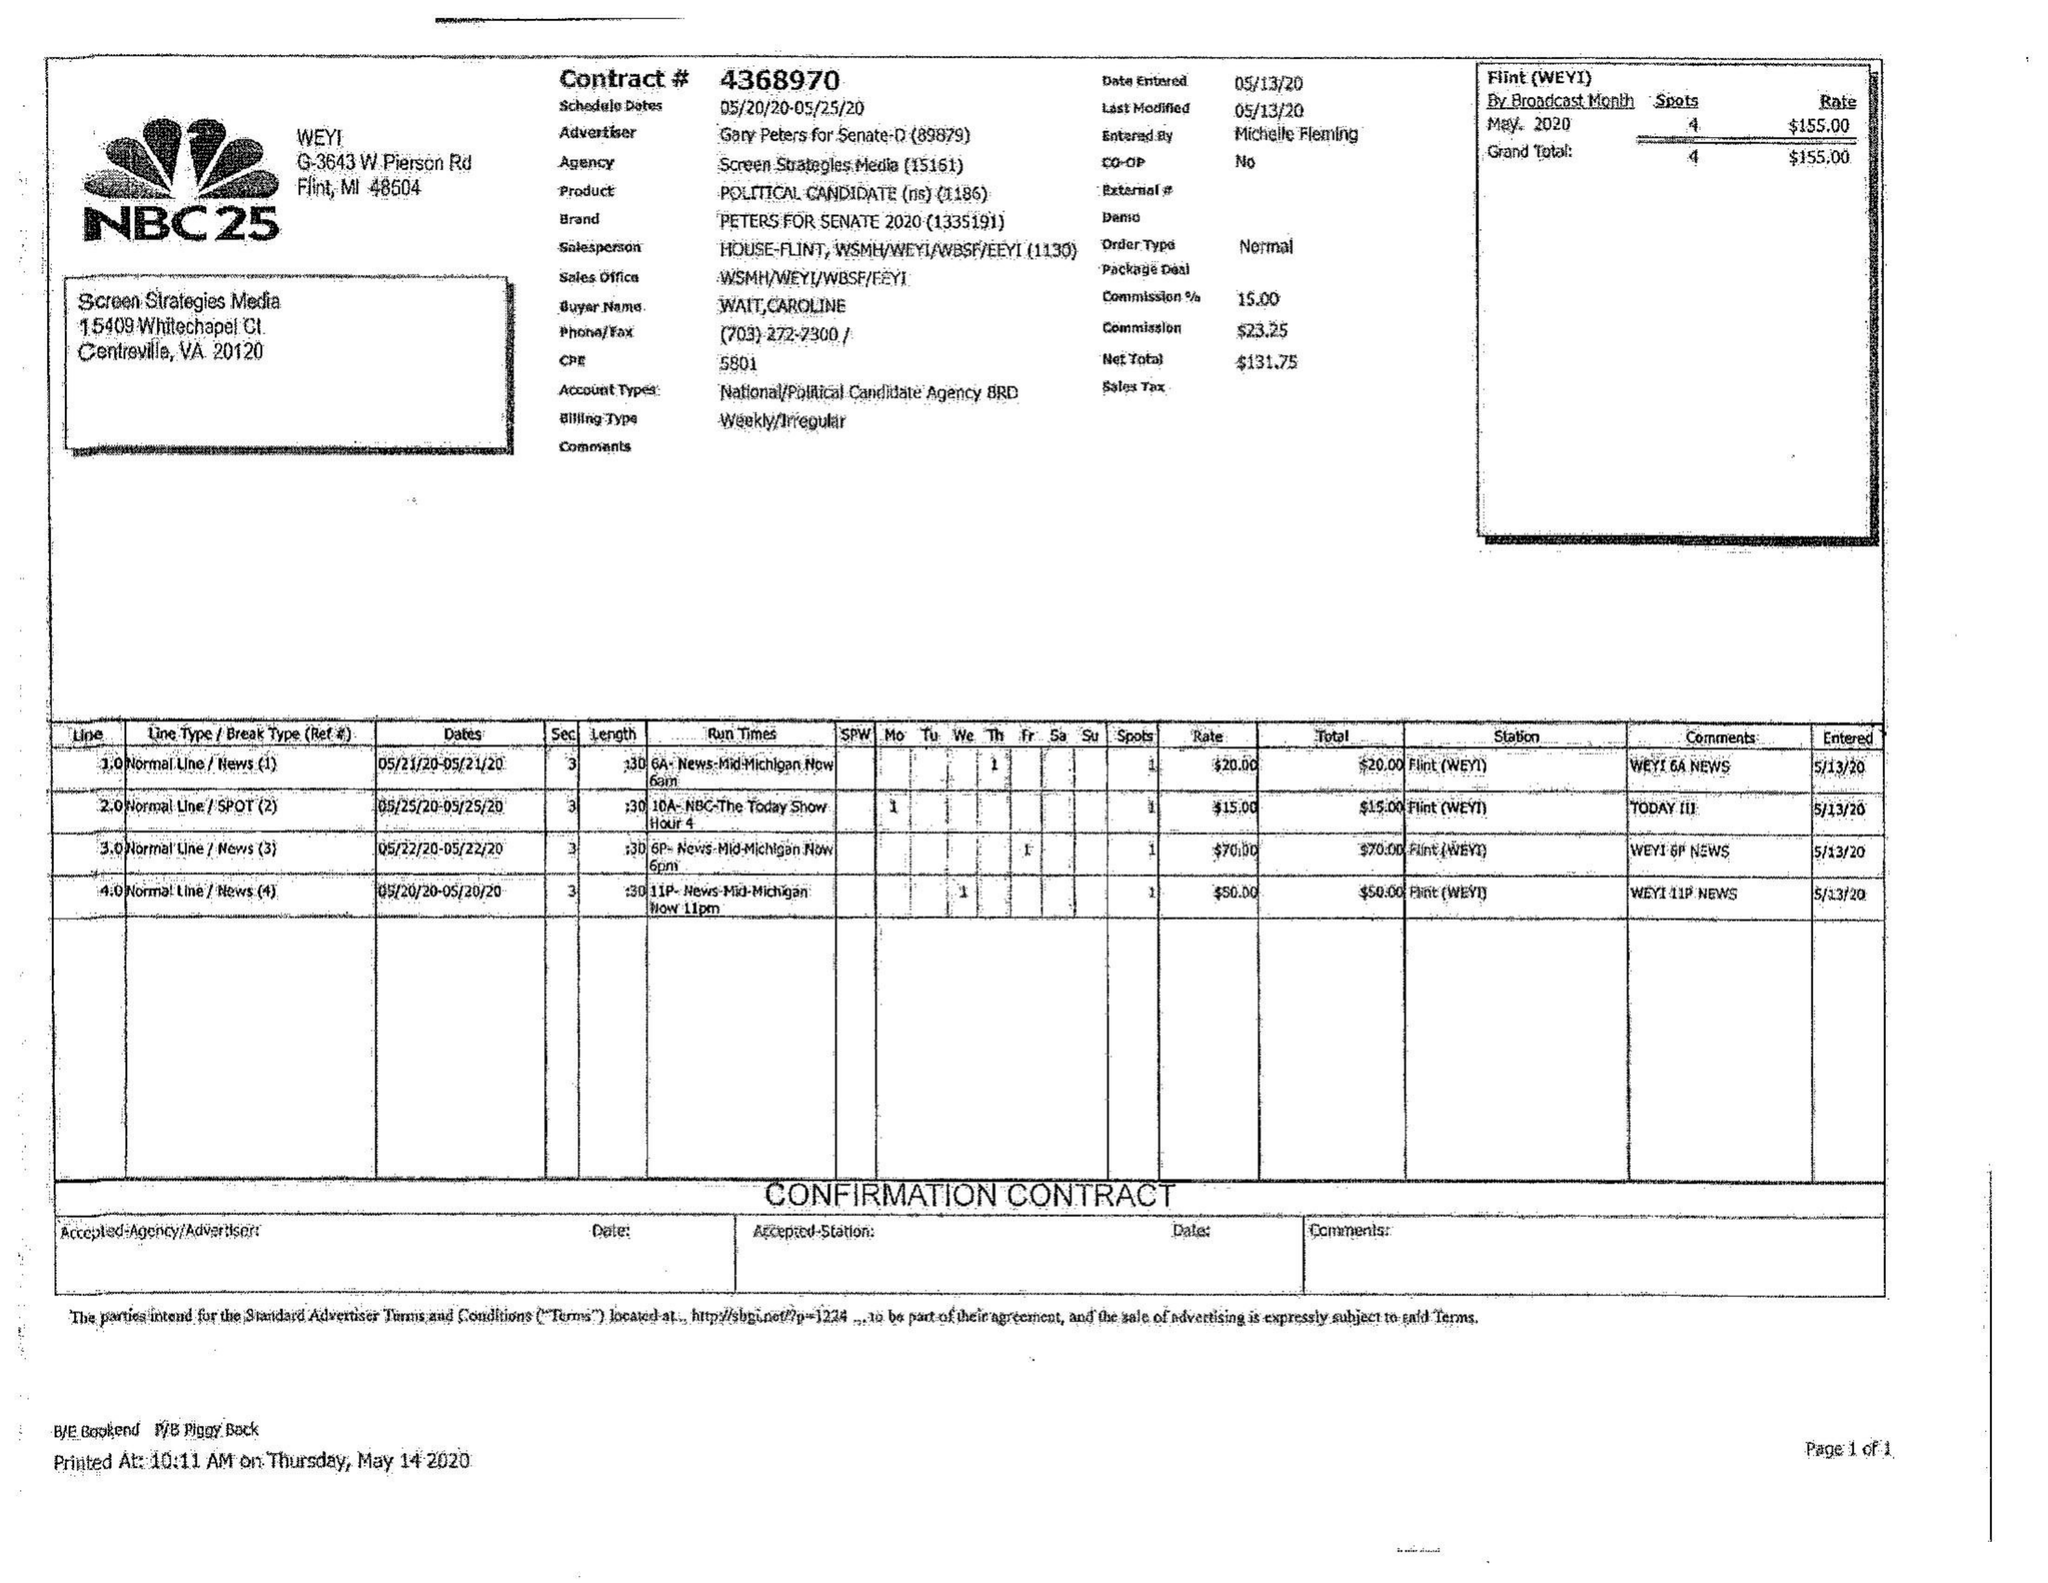What is the value for the advertiser?
Answer the question using a single word or phrase. GARY PETERS FOR SENATE-D 